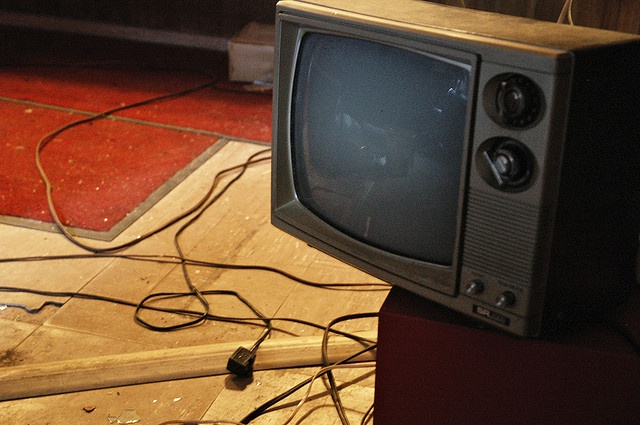Describe the objects in this image and their specific colors. I can see a tv in black, purple, and darkblue tones in this image. 